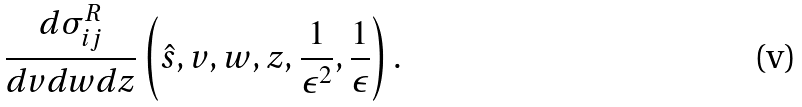<formula> <loc_0><loc_0><loc_500><loc_500>\frac { d \sigma ^ { R } _ { i j } } { d v d w d z } \left ( \hat { s } , v , w , z , \frac { 1 } { \epsilon ^ { 2 } } , \frac { 1 } { \epsilon } \right ) .</formula> 